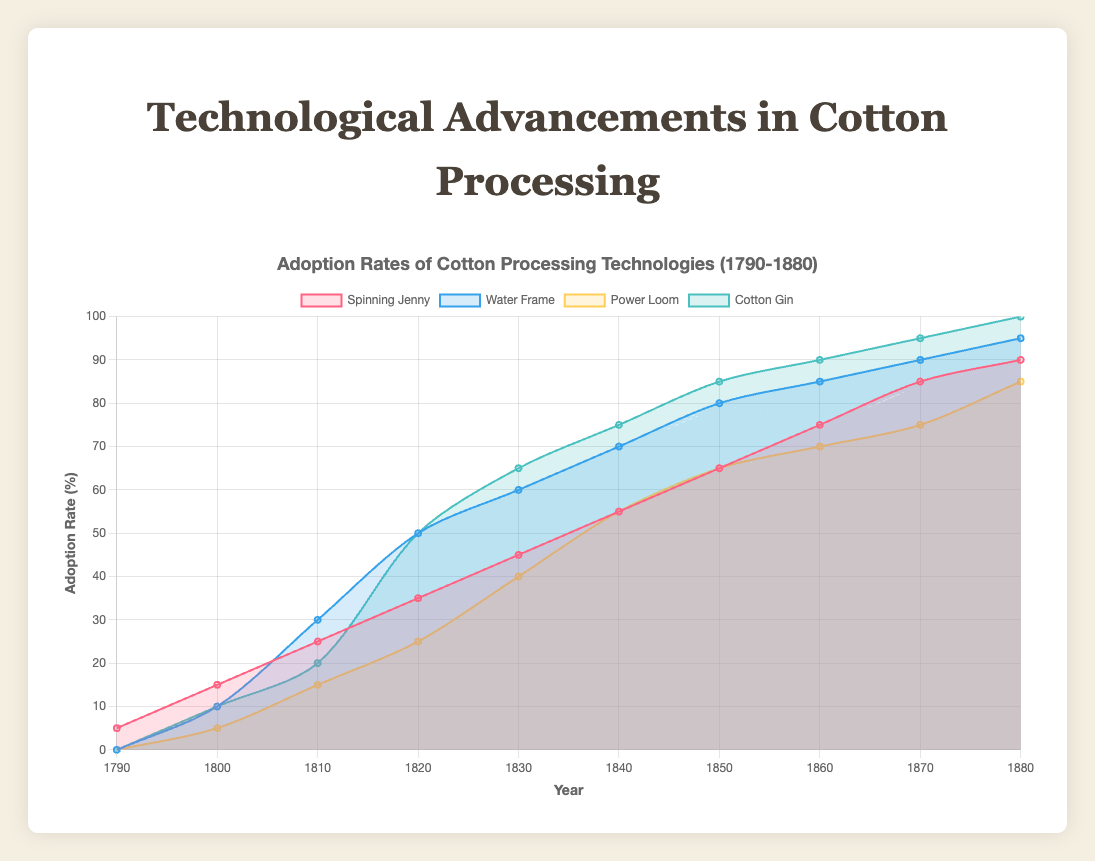What is the title of the chart? The title of the chart is located at the top and it specifies what the chart is about.
Answer: Adoption Rates of Cotton Processing Technologies (1790-1880) Which technological advancement reached an adoption rate of 100% by 1880? By looking at the end of each line (1880), identify the line that touches 100% on the y-axis.
Answer: Cotton Gin How did the adoption rate of the Spinning Jenny change from 1790 to 1880? Follow the line representing the Spinning Jenny from 1790 to 1880 and note the changes in its adoption rate.
Answer: It increased from 5% to 90% Which technology had the highest adoption rate in 1820? Compare the adoption rates of all the technologies at the year 1820 on the x-axis.
Answer: Cotton Gin (50%) Which technology saw the most rapid increase in adoption rate between 1820 and 1830? Compare the slopes of the lines between 1820 and 1830; the steepest slope indicates the most rapid increase.
Answer: Cotton Gin Compare the adoption rates of the Power Loom and Water Frame in 1850. Which had a higher rate? At the year 1850, compare the adoption rates of Power Loom and Water Frame.
Answer: Water Frame What is the average adoption rate of the Power Loom between 1800 and 1880? Add the adoption rates of the Power Loom from 1800 to 1880 and divide by the number of data points (9).
Answer: Average = (5+15+25+40+55+65+70+75+85) / 9 = 48.33% Did any technology reach an adoption rate over 50% by 1840? Check if any lines crossed the 50% mark on the y-axis by the year 1840.
Answer: Yes, Water Frame and Cotton Gin Between which years did the Spinning Jenny adoption rate increase the most? Compare the increments of the Spinning Jenny’s adoption rate at different time intervals to determine the largest increase.
Answer: 1790 to 1800 